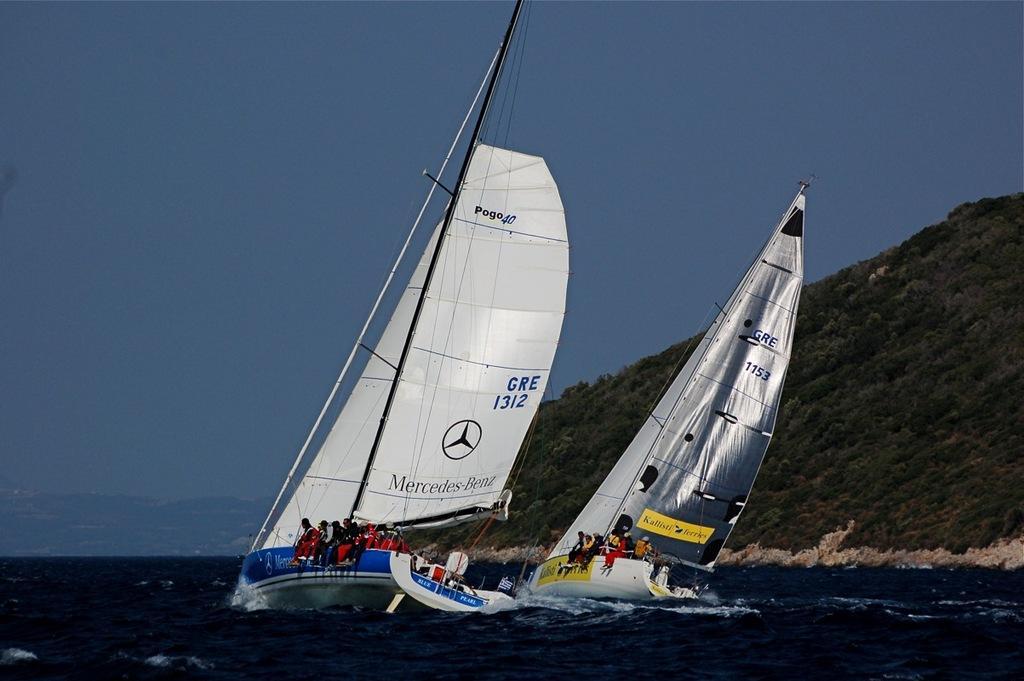Can you describe this image briefly? In the foreground, I can see a group of people in the boats and I can see water. In the background, I can see trees, mountains and the sky. This image taken, maybe in the ocean. 